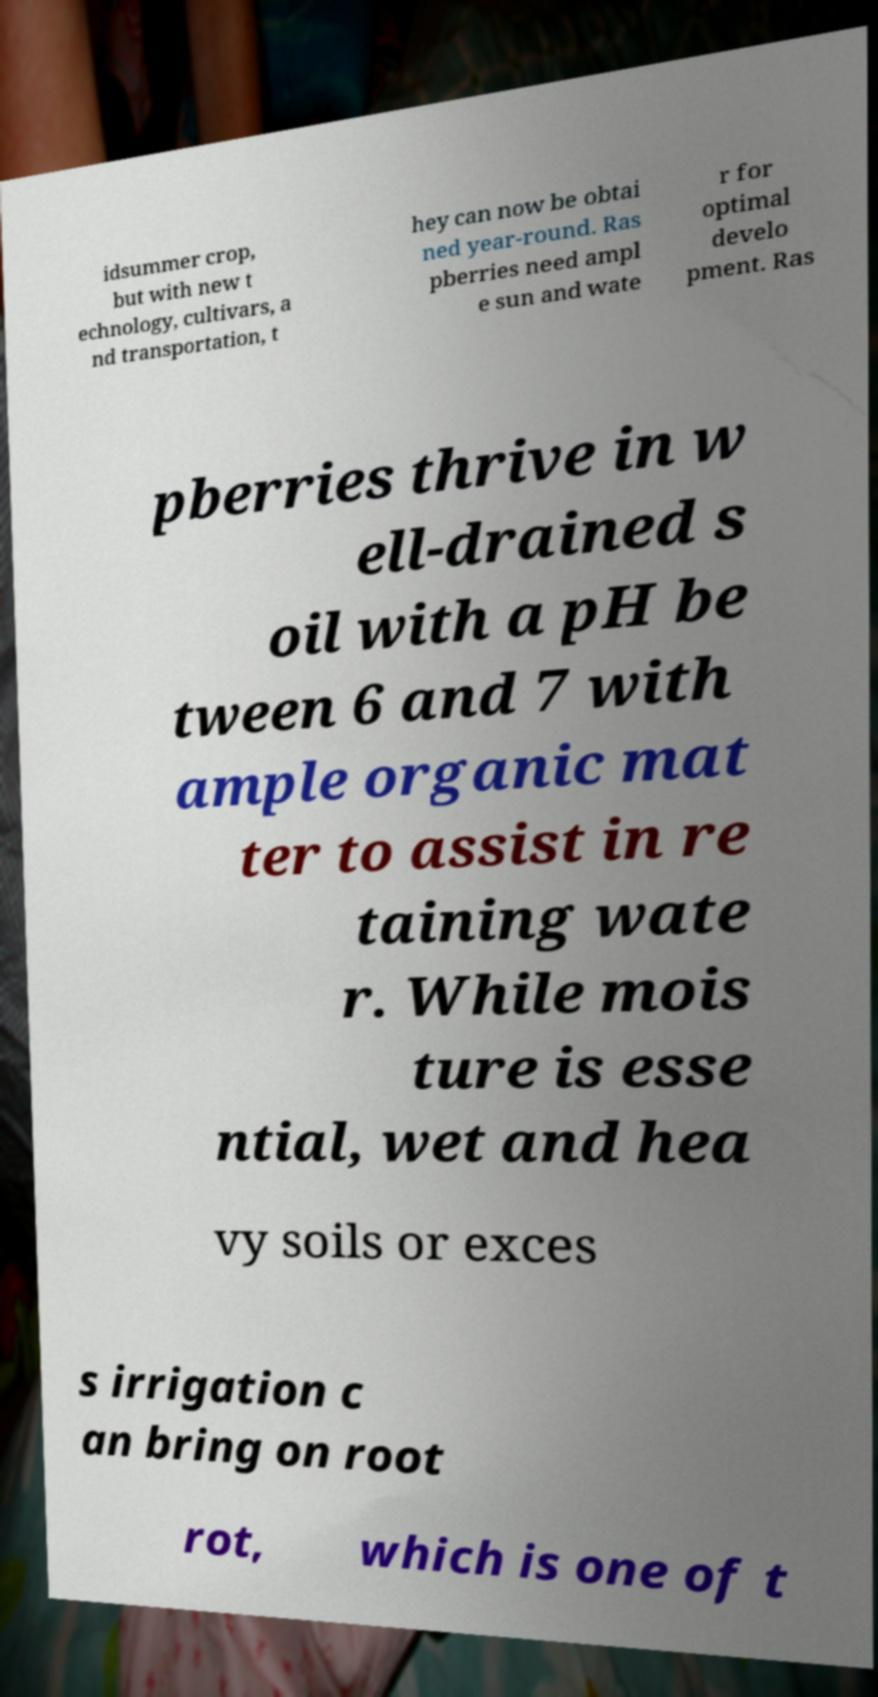Could you extract and type out the text from this image? idsummer crop, but with new t echnology, cultivars, a nd transportation, t hey can now be obtai ned year-round. Ras pberries need ampl e sun and wate r for optimal develo pment. Ras pberries thrive in w ell-drained s oil with a pH be tween 6 and 7 with ample organic mat ter to assist in re taining wate r. While mois ture is esse ntial, wet and hea vy soils or exces s irrigation c an bring on root rot, which is one of t 